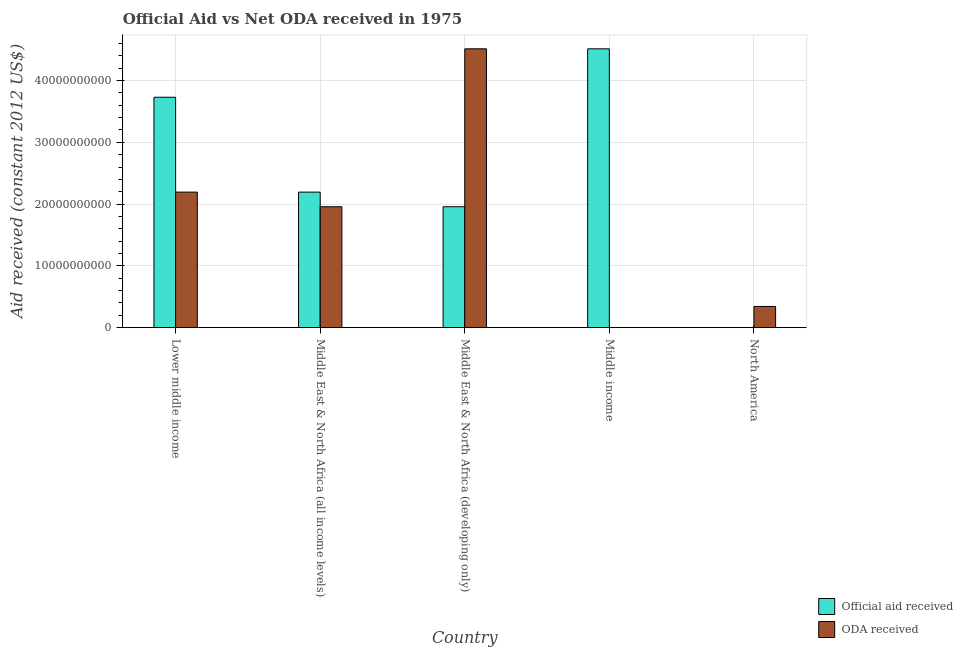Are the number of bars on each tick of the X-axis equal?
Your answer should be compact. Yes. What is the label of the 2nd group of bars from the left?
Make the answer very short. Middle East & North Africa (all income levels). What is the oda received in Lower middle income?
Give a very brief answer. 2.19e+1. Across all countries, what is the maximum oda received?
Keep it short and to the point. 4.51e+1. Across all countries, what is the minimum official aid received?
Your response must be concise. 9.00e+04. In which country was the oda received maximum?
Ensure brevity in your answer.  Middle East & North Africa (developing only). In which country was the oda received minimum?
Your answer should be compact. Middle income. What is the total oda received in the graph?
Your answer should be compact. 9.01e+1. What is the difference between the official aid received in Lower middle income and that in North America?
Keep it short and to the point. 3.73e+1. What is the difference between the oda received in Middle East & North Africa (developing only) and the official aid received in Middle East & North Africa (all income levels)?
Make the answer very short. 2.32e+1. What is the average oda received per country?
Your answer should be compact. 1.80e+1. What is the difference between the oda received and official aid received in Middle East & North Africa (developing only)?
Your response must be concise. 2.56e+1. What is the ratio of the official aid received in Middle East & North Africa (all income levels) to that in North America?
Offer a very short reply. 2.44e+05. Is the oda received in Middle East & North Africa (all income levels) less than that in Middle East & North Africa (developing only)?
Make the answer very short. Yes. Is the difference between the oda received in Lower middle income and Middle East & North Africa (all income levels) greater than the difference between the official aid received in Lower middle income and Middle East & North Africa (all income levels)?
Ensure brevity in your answer.  No. What is the difference between the highest and the second highest oda received?
Your answer should be very brief. 2.32e+1. What is the difference between the highest and the lowest official aid received?
Provide a succinct answer. 4.51e+1. In how many countries, is the official aid received greater than the average official aid received taken over all countries?
Ensure brevity in your answer.  2. Is the sum of the oda received in Middle East & North Africa (developing only) and North America greater than the maximum official aid received across all countries?
Your response must be concise. Yes. What does the 2nd bar from the left in Middle East & North Africa (developing only) represents?
Your answer should be compact. ODA received. What does the 2nd bar from the right in Middle East & North Africa (all income levels) represents?
Give a very brief answer. Official aid received. How many bars are there?
Your answer should be compact. 10. Are all the bars in the graph horizontal?
Offer a very short reply. No. How many countries are there in the graph?
Give a very brief answer. 5. Does the graph contain any zero values?
Your answer should be compact. No. Does the graph contain grids?
Offer a very short reply. Yes. Where does the legend appear in the graph?
Give a very brief answer. Bottom right. How many legend labels are there?
Your answer should be compact. 2. What is the title of the graph?
Offer a very short reply. Official Aid vs Net ODA received in 1975 . Does "% of GNI" appear as one of the legend labels in the graph?
Keep it short and to the point. No. What is the label or title of the X-axis?
Keep it short and to the point. Country. What is the label or title of the Y-axis?
Provide a short and direct response. Aid received (constant 2012 US$). What is the Aid received (constant 2012 US$) in Official aid received in Lower middle income?
Provide a succinct answer. 3.73e+1. What is the Aid received (constant 2012 US$) in ODA received in Lower middle income?
Your answer should be very brief. 2.19e+1. What is the Aid received (constant 2012 US$) of Official aid received in Middle East & North Africa (all income levels)?
Your answer should be compact. 2.19e+1. What is the Aid received (constant 2012 US$) of ODA received in Middle East & North Africa (all income levels)?
Offer a very short reply. 1.96e+1. What is the Aid received (constant 2012 US$) in Official aid received in Middle East & North Africa (developing only)?
Provide a short and direct response. 1.96e+1. What is the Aid received (constant 2012 US$) of ODA received in Middle East & North Africa (developing only)?
Your response must be concise. 4.51e+1. What is the Aid received (constant 2012 US$) in Official aid received in Middle income?
Your response must be concise. 4.51e+1. What is the Aid received (constant 2012 US$) of Official aid received in North America?
Your answer should be very brief. 9.00e+04. What is the Aid received (constant 2012 US$) of ODA received in North America?
Make the answer very short. 3.44e+09. Across all countries, what is the maximum Aid received (constant 2012 US$) of Official aid received?
Your response must be concise. 4.51e+1. Across all countries, what is the maximum Aid received (constant 2012 US$) of ODA received?
Your answer should be very brief. 4.51e+1. Across all countries, what is the minimum Aid received (constant 2012 US$) in Official aid received?
Provide a succinct answer. 9.00e+04. What is the total Aid received (constant 2012 US$) of Official aid received in the graph?
Your answer should be compact. 1.24e+11. What is the total Aid received (constant 2012 US$) of ODA received in the graph?
Provide a succinct answer. 9.01e+1. What is the difference between the Aid received (constant 2012 US$) in Official aid received in Lower middle income and that in Middle East & North Africa (all income levels)?
Your answer should be very brief. 1.54e+1. What is the difference between the Aid received (constant 2012 US$) of ODA received in Lower middle income and that in Middle East & North Africa (all income levels)?
Your answer should be very brief. 2.36e+09. What is the difference between the Aid received (constant 2012 US$) in Official aid received in Lower middle income and that in Middle East & North Africa (developing only)?
Your response must be concise. 1.77e+1. What is the difference between the Aid received (constant 2012 US$) of ODA received in Lower middle income and that in Middle East & North Africa (developing only)?
Give a very brief answer. -2.32e+1. What is the difference between the Aid received (constant 2012 US$) in Official aid received in Lower middle income and that in Middle income?
Make the answer very short. -7.84e+09. What is the difference between the Aid received (constant 2012 US$) in ODA received in Lower middle income and that in Middle income?
Offer a terse response. 2.19e+1. What is the difference between the Aid received (constant 2012 US$) in Official aid received in Lower middle income and that in North America?
Provide a succinct answer. 3.73e+1. What is the difference between the Aid received (constant 2012 US$) in ODA received in Lower middle income and that in North America?
Keep it short and to the point. 1.85e+1. What is the difference between the Aid received (constant 2012 US$) in Official aid received in Middle East & North Africa (all income levels) and that in Middle East & North Africa (developing only)?
Keep it short and to the point. 2.36e+09. What is the difference between the Aid received (constant 2012 US$) of ODA received in Middle East & North Africa (all income levels) and that in Middle East & North Africa (developing only)?
Make the answer very short. -2.56e+1. What is the difference between the Aid received (constant 2012 US$) in Official aid received in Middle East & North Africa (all income levels) and that in Middle income?
Offer a terse response. -2.32e+1. What is the difference between the Aid received (constant 2012 US$) of ODA received in Middle East & North Africa (all income levels) and that in Middle income?
Your answer should be compact. 1.96e+1. What is the difference between the Aid received (constant 2012 US$) of Official aid received in Middle East & North Africa (all income levels) and that in North America?
Provide a short and direct response. 2.19e+1. What is the difference between the Aid received (constant 2012 US$) in ODA received in Middle East & North Africa (all income levels) and that in North America?
Your answer should be very brief. 1.61e+1. What is the difference between the Aid received (constant 2012 US$) in Official aid received in Middle East & North Africa (developing only) and that in Middle income?
Your answer should be compact. -2.56e+1. What is the difference between the Aid received (constant 2012 US$) of ODA received in Middle East & North Africa (developing only) and that in Middle income?
Offer a very short reply. 4.51e+1. What is the difference between the Aid received (constant 2012 US$) in Official aid received in Middle East & North Africa (developing only) and that in North America?
Give a very brief answer. 1.96e+1. What is the difference between the Aid received (constant 2012 US$) in ODA received in Middle East & North Africa (developing only) and that in North America?
Ensure brevity in your answer.  4.17e+1. What is the difference between the Aid received (constant 2012 US$) in Official aid received in Middle income and that in North America?
Make the answer very short. 4.51e+1. What is the difference between the Aid received (constant 2012 US$) of ODA received in Middle income and that in North America?
Your answer should be compact. -3.44e+09. What is the difference between the Aid received (constant 2012 US$) of Official aid received in Lower middle income and the Aid received (constant 2012 US$) of ODA received in Middle East & North Africa (all income levels)?
Ensure brevity in your answer.  1.77e+1. What is the difference between the Aid received (constant 2012 US$) of Official aid received in Lower middle income and the Aid received (constant 2012 US$) of ODA received in Middle East & North Africa (developing only)?
Ensure brevity in your answer.  -7.84e+09. What is the difference between the Aid received (constant 2012 US$) of Official aid received in Lower middle income and the Aid received (constant 2012 US$) of ODA received in Middle income?
Your answer should be compact. 3.73e+1. What is the difference between the Aid received (constant 2012 US$) of Official aid received in Lower middle income and the Aid received (constant 2012 US$) of ODA received in North America?
Offer a very short reply. 3.39e+1. What is the difference between the Aid received (constant 2012 US$) in Official aid received in Middle East & North Africa (all income levels) and the Aid received (constant 2012 US$) in ODA received in Middle East & North Africa (developing only)?
Your answer should be compact. -2.32e+1. What is the difference between the Aid received (constant 2012 US$) in Official aid received in Middle East & North Africa (all income levels) and the Aid received (constant 2012 US$) in ODA received in Middle income?
Offer a very short reply. 2.19e+1. What is the difference between the Aid received (constant 2012 US$) of Official aid received in Middle East & North Africa (all income levels) and the Aid received (constant 2012 US$) of ODA received in North America?
Your answer should be very brief. 1.85e+1. What is the difference between the Aid received (constant 2012 US$) in Official aid received in Middle East & North Africa (developing only) and the Aid received (constant 2012 US$) in ODA received in Middle income?
Make the answer very short. 1.96e+1. What is the difference between the Aid received (constant 2012 US$) of Official aid received in Middle East & North Africa (developing only) and the Aid received (constant 2012 US$) of ODA received in North America?
Your answer should be very brief. 1.61e+1. What is the difference between the Aid received (constant 2012 US$) in Official aid received in Middle income and the Aid received (constant 2012 US$) in ODA received in North America?
Your answer should be compact. 4.17e+1. What is the average Aid received (constant 2012 US$) of Official aid received per country?
Offer a terse response. 2.48e+1. What is the average Aid received (constant 2012 US$) of ODA received per country?
Your response must be concise. 1.80e+1. What is the difference between the Aid received (constant 2012 US$) in Official aid received and Aid received (constant 2012 US$) in ODA received in Lower middle income?
Provide a succinct answer. 1.54e+1. What is the difference between the Aid received (constant 2012 US$) in Official aid received and Aid received (constant 2012 US$) in ODA received in Middle East & North Africa (all income levels)?
Offer a terse response. 2.36e+09. What is the difference between the Aid received (constant 2012 US$) in Official aid received and Aid received (constant 2012 US$) in ODA received in Middle East & North Africa (developing only)?
Your answer should be very brief. -2.56e+1. What is the difference between the Aid received (constant 2012 US$) of Official aid received and Aid received (constant 2012 US$) of ODA received in Middle income?
Your response must be concise. 4.51e+1. What is the difference between the Aid received (constant 2012 US$) in Official aid received and Aid received (constant 2012 US$) in ODA received in North America?
Your answer should be compact. -3.44e+09. What is the ratio of the Aid received (constant 2012 US$) of Official aid received in Lower middle income to that in Middle East & North Africa (all income levels)?
Your response must be concise. 1.7. What is the ratio of the Aid received (constant 2012 US$) in ODA received in Lower middle income to that in Middle East & North Africa (all income levels)?
Your response must be concise. 1.12. What is the ratio of the Aid received (constant 2012 US$) of Official aid received in Lower middle income to that in Middle East & North Africa (developing only)?
Your answer should be compact. 1.91. What is the ratio of the Aid received (constant 2012 US$) of ODA received in Lower middle income to that in Middle East & North Africa (developing only)?
Offer a terse response. 0.49. What is the ratio of the Aid received (constant 2012 US$) of Official aid received in Lower middle income to that in Middle income?
Make the answer very short. 0.83. What is the ratio of the Aid received (constant 2012 US$) of ODA received in Lower middle income to that in Middle income?
Your response must be concise. 2.44e+05. What is the ratio of the Aid received (constant 2012 US$) in Official aid received in Lower middle income to that in North America?
Provide a succinct answer. 4.14e+05. What is the ratio of the Aid received (constant 2012 US$) of ODA received in Lower middle income to that in North America?
Your answer should be compact. 6.39. What is the ratio of the Aid received (constant 2012 US$) in Official aid received in Middle East & North Africa (all income levels) to that in Middle East & North Africa (developing only)?
Keep it short and to the point. 1.12. What is the ratio of the Aid received (constant 2012 US$) in ODA received in Middle East & North Africa (all income levels) to that in Middle East & North Africa (developing only)?
Make the answer very short. 0.43. What is the ratio of the Aid received (constant 2012 US$) in Official aid received in Middle East & North Africa (all income levels) to that in Middle income?
Your answer should be very brief. 0.49. What is the ratio of the Aid received (constant 2012 US$) in ODA received in Middle East & North Africa (all income levels) to that in Middle income?
Provide a short and direct response. 2.18e+05. What is the ratio of the Aid received (constant 2012 US$) in Official aid received in Middle East & North Africa (all income levels) to that in North America?
Give a very brief answer. 2.44e+05. What is the ratio of the Aid received (constant 2012 US$) of ODA received in Middle East & North Africa (all income levels) to that in North America?
Provide a short and direct response. 5.7. What is the ratio of the Aid received (constant 2012 US$) in Official aid received in Middle East & North Africa (developing only) to that in Middle income?
Offer a very short reply. 0.43. What is the ratio of the Aid received (constant 2012 US$) of ODA received in Middle East & North Africa (developing only) to that in Middle income?
Offer a very short reply. 5.02e+05. What is the ratio of the Aid received (constant 2012 US$) in Official aid received in Middle East & North Africa (developing only) to that in North America?
Give a very brief answer. 2.18e+05. What is the ratio of the Aid received (constant 2012 US$) of ODA received in Middle East & North Africa (developing only) to that in North America?
Provide a succinct answer. 13.14. What is the ratio of the Aid received (constant 2012 US$) of Official aid received in Middle income to that in North America?
Offer a very short reply. 5.02e+05. What is the difference between the highest and the second highest Aid received (constant 2012 US$) in Official aid received?
Provide a short and direct response. 7.84e+09. What is the difference between the highest and the second highest Aid received (constant 2012 US$) of ODA received?
Make the answer very short. 2.32e+1. What is the difference between the highest and the lowest Aid received (constant 2012 US$) in Official aid received?
Your answer should be compact. 4.51e+1. What is the difference between the highest and the lowest Aid received (constant 2012 US$) of ODA received?
Provide a short and direct response. 4.51e+1. 